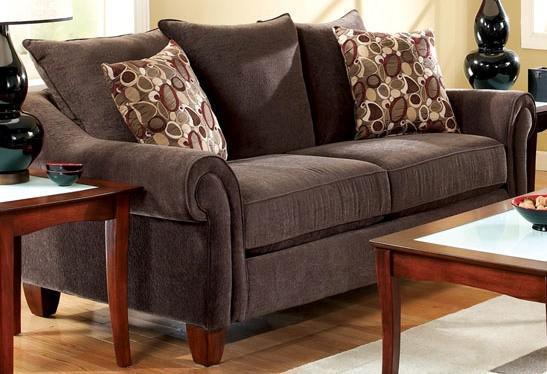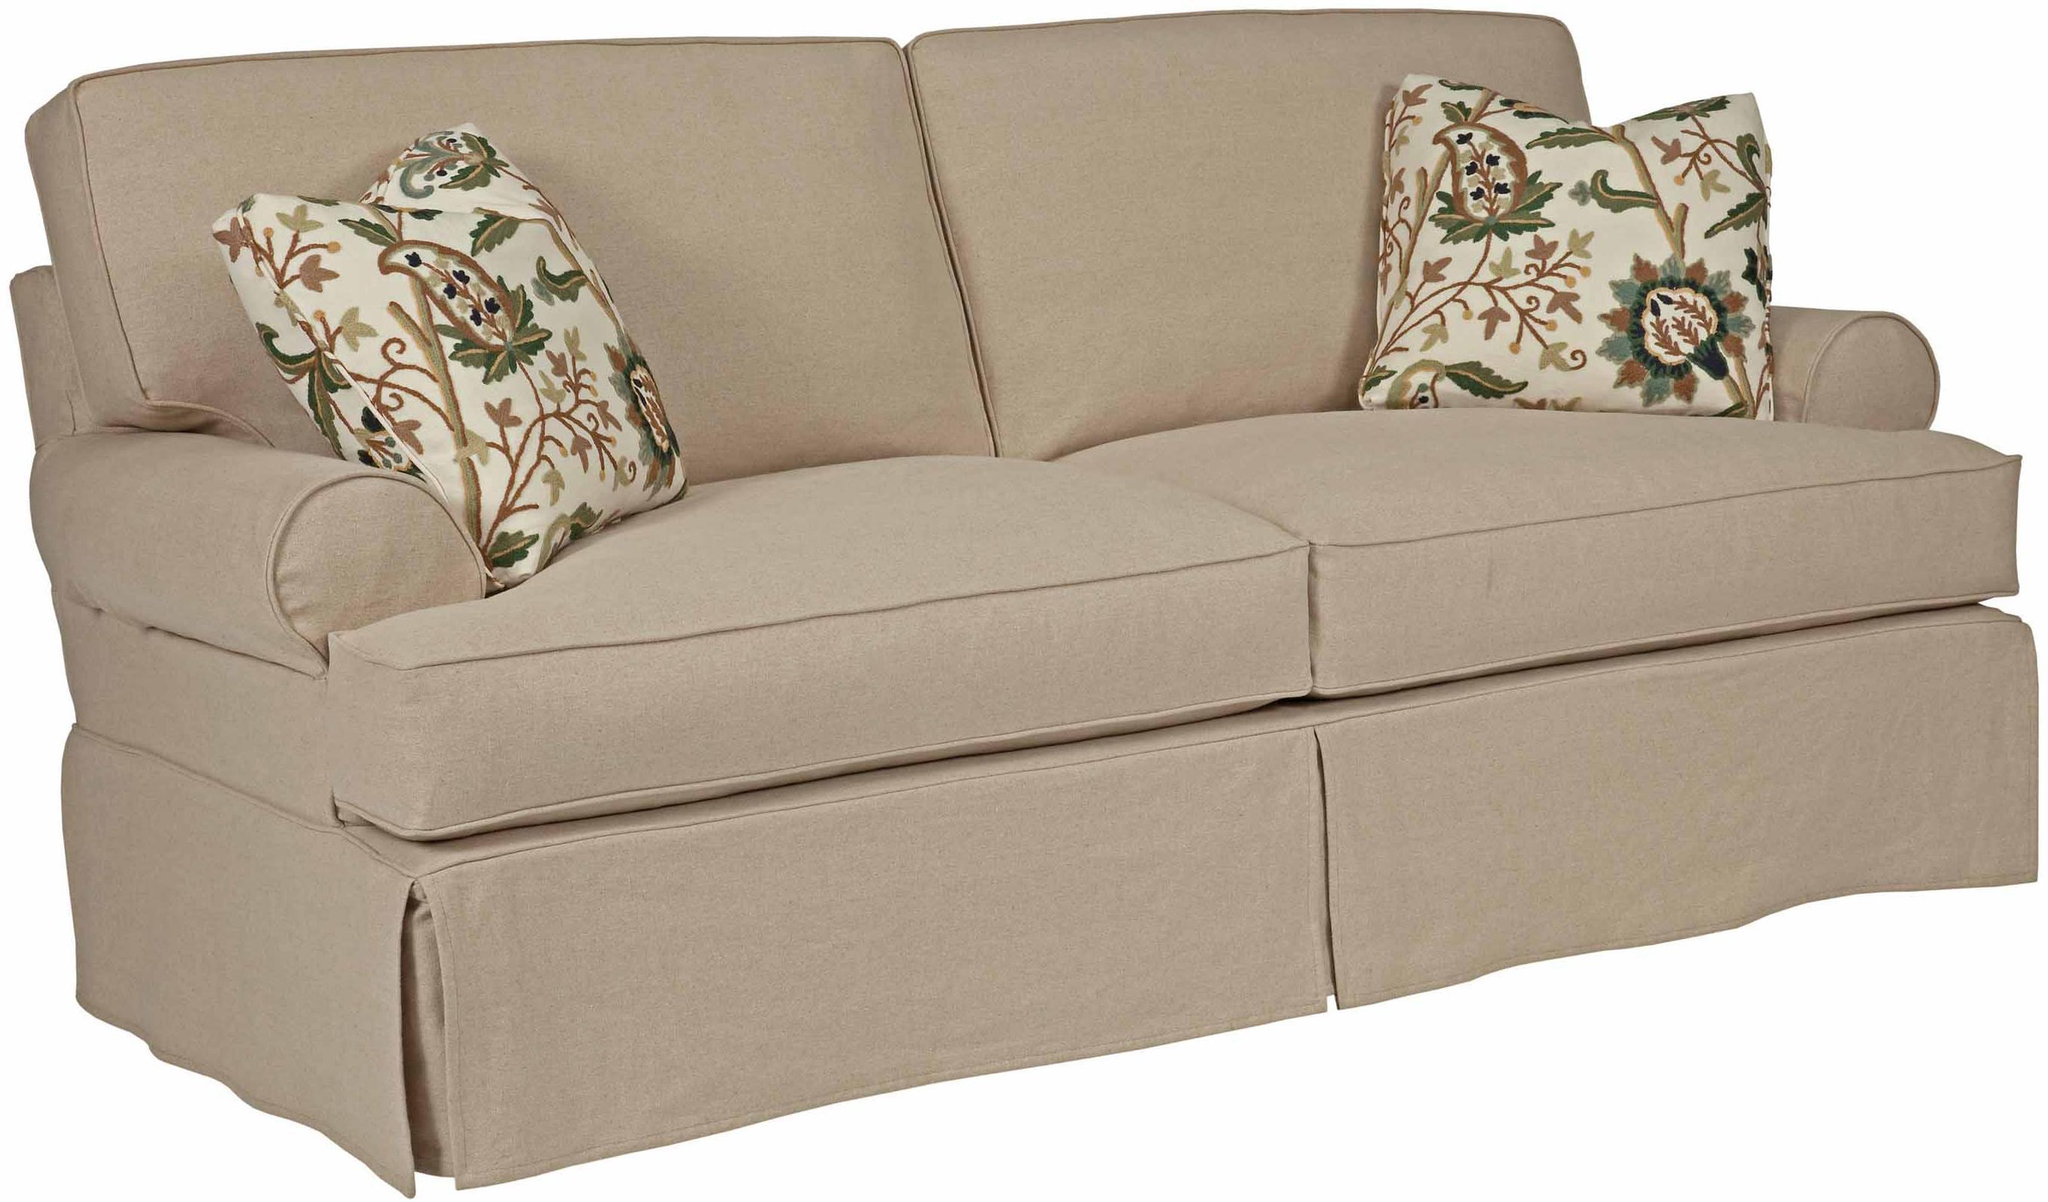The first image is the image on the left, the second image is the image on the right. For the images displayed, is the sentence "There are two throw pillows with different color circle patterns sitting on top of a sofa." factually correct? Answer yes or no. Yes. The first image is the image on the left, the second image is the image on the right. Analyze the images presented: Is the assertion "Each image features one diagonally-displayed three-cushion footed couch, with two matching patterned pillows positioned one on each end of the couch." valid? Answer yes or no. No. 